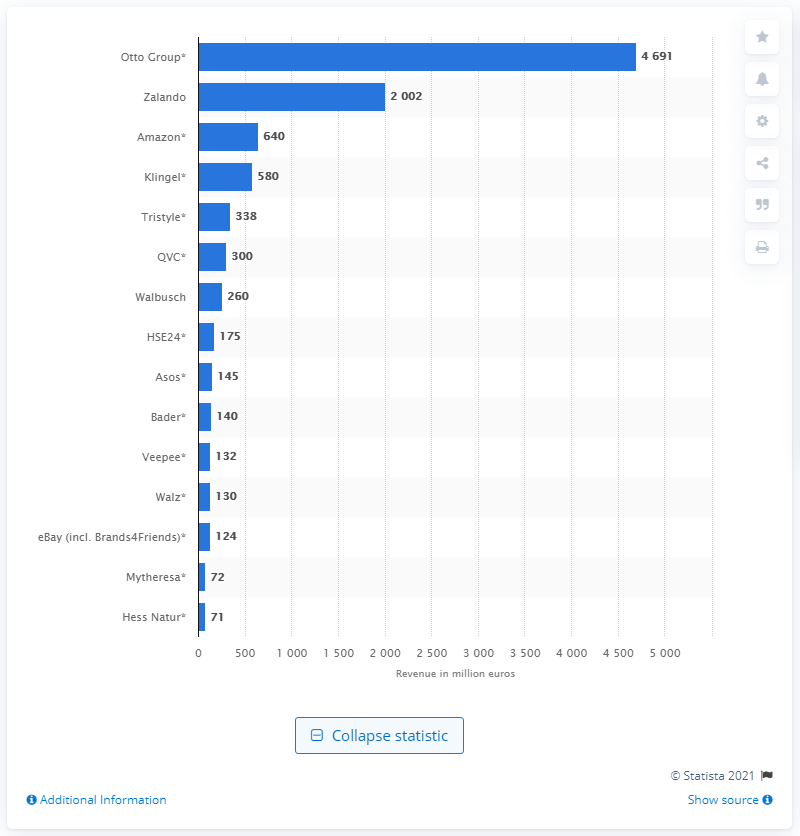Indicate a few pertinent items in this graphic. The Otto Group generated 4691 from product sales in revenue. 